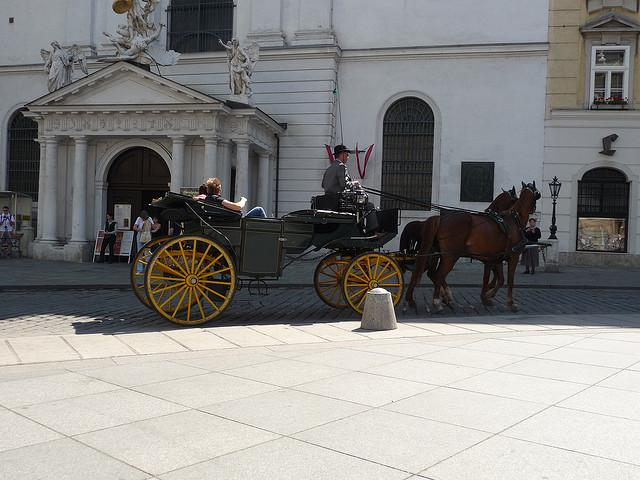What is being held by the person sitting highest? reins 